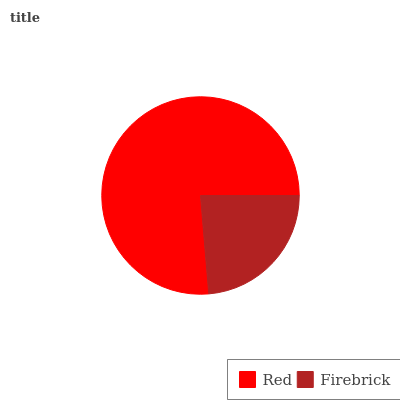Is Firebrick the minimum?
Answer yes or no. Yes. Is Red the maximum?
Answer yes or no. Yes. Is Firebrick the maximum?
Answer yes or no. No. Is Red greater than Firebrick?
Answer yes or no. Yes. Is Firebrick less than Red?
Answer yes or no. Yes. Is Firebrick greater than Red?
Answer yes or no. No. Is Red less than Firebrick?
Answer yes or no. No. Is Red the high median?
Answer yes or no. Yes. Is Firebrick the low median?
Answer yes or no. Yes. Is Firebrick the high median?
Answer yes or no. No. Is Red the low median?
Answer yes or no. No. 